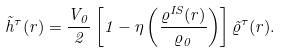<formula> <loc_0><loc_0><loc_500><loc_500>\tilde { h } ^ { \tau } ( r ) = \frac { V _ { 0 } } { 2 } \left [ 1 - \eta \left ( \frac { \varrho ^ { I S } ( r ) } { \varrho _ { 0 } } \right ) \right ] \tilde { \varrho } ^ { \tau } ( r ) .</formula> 